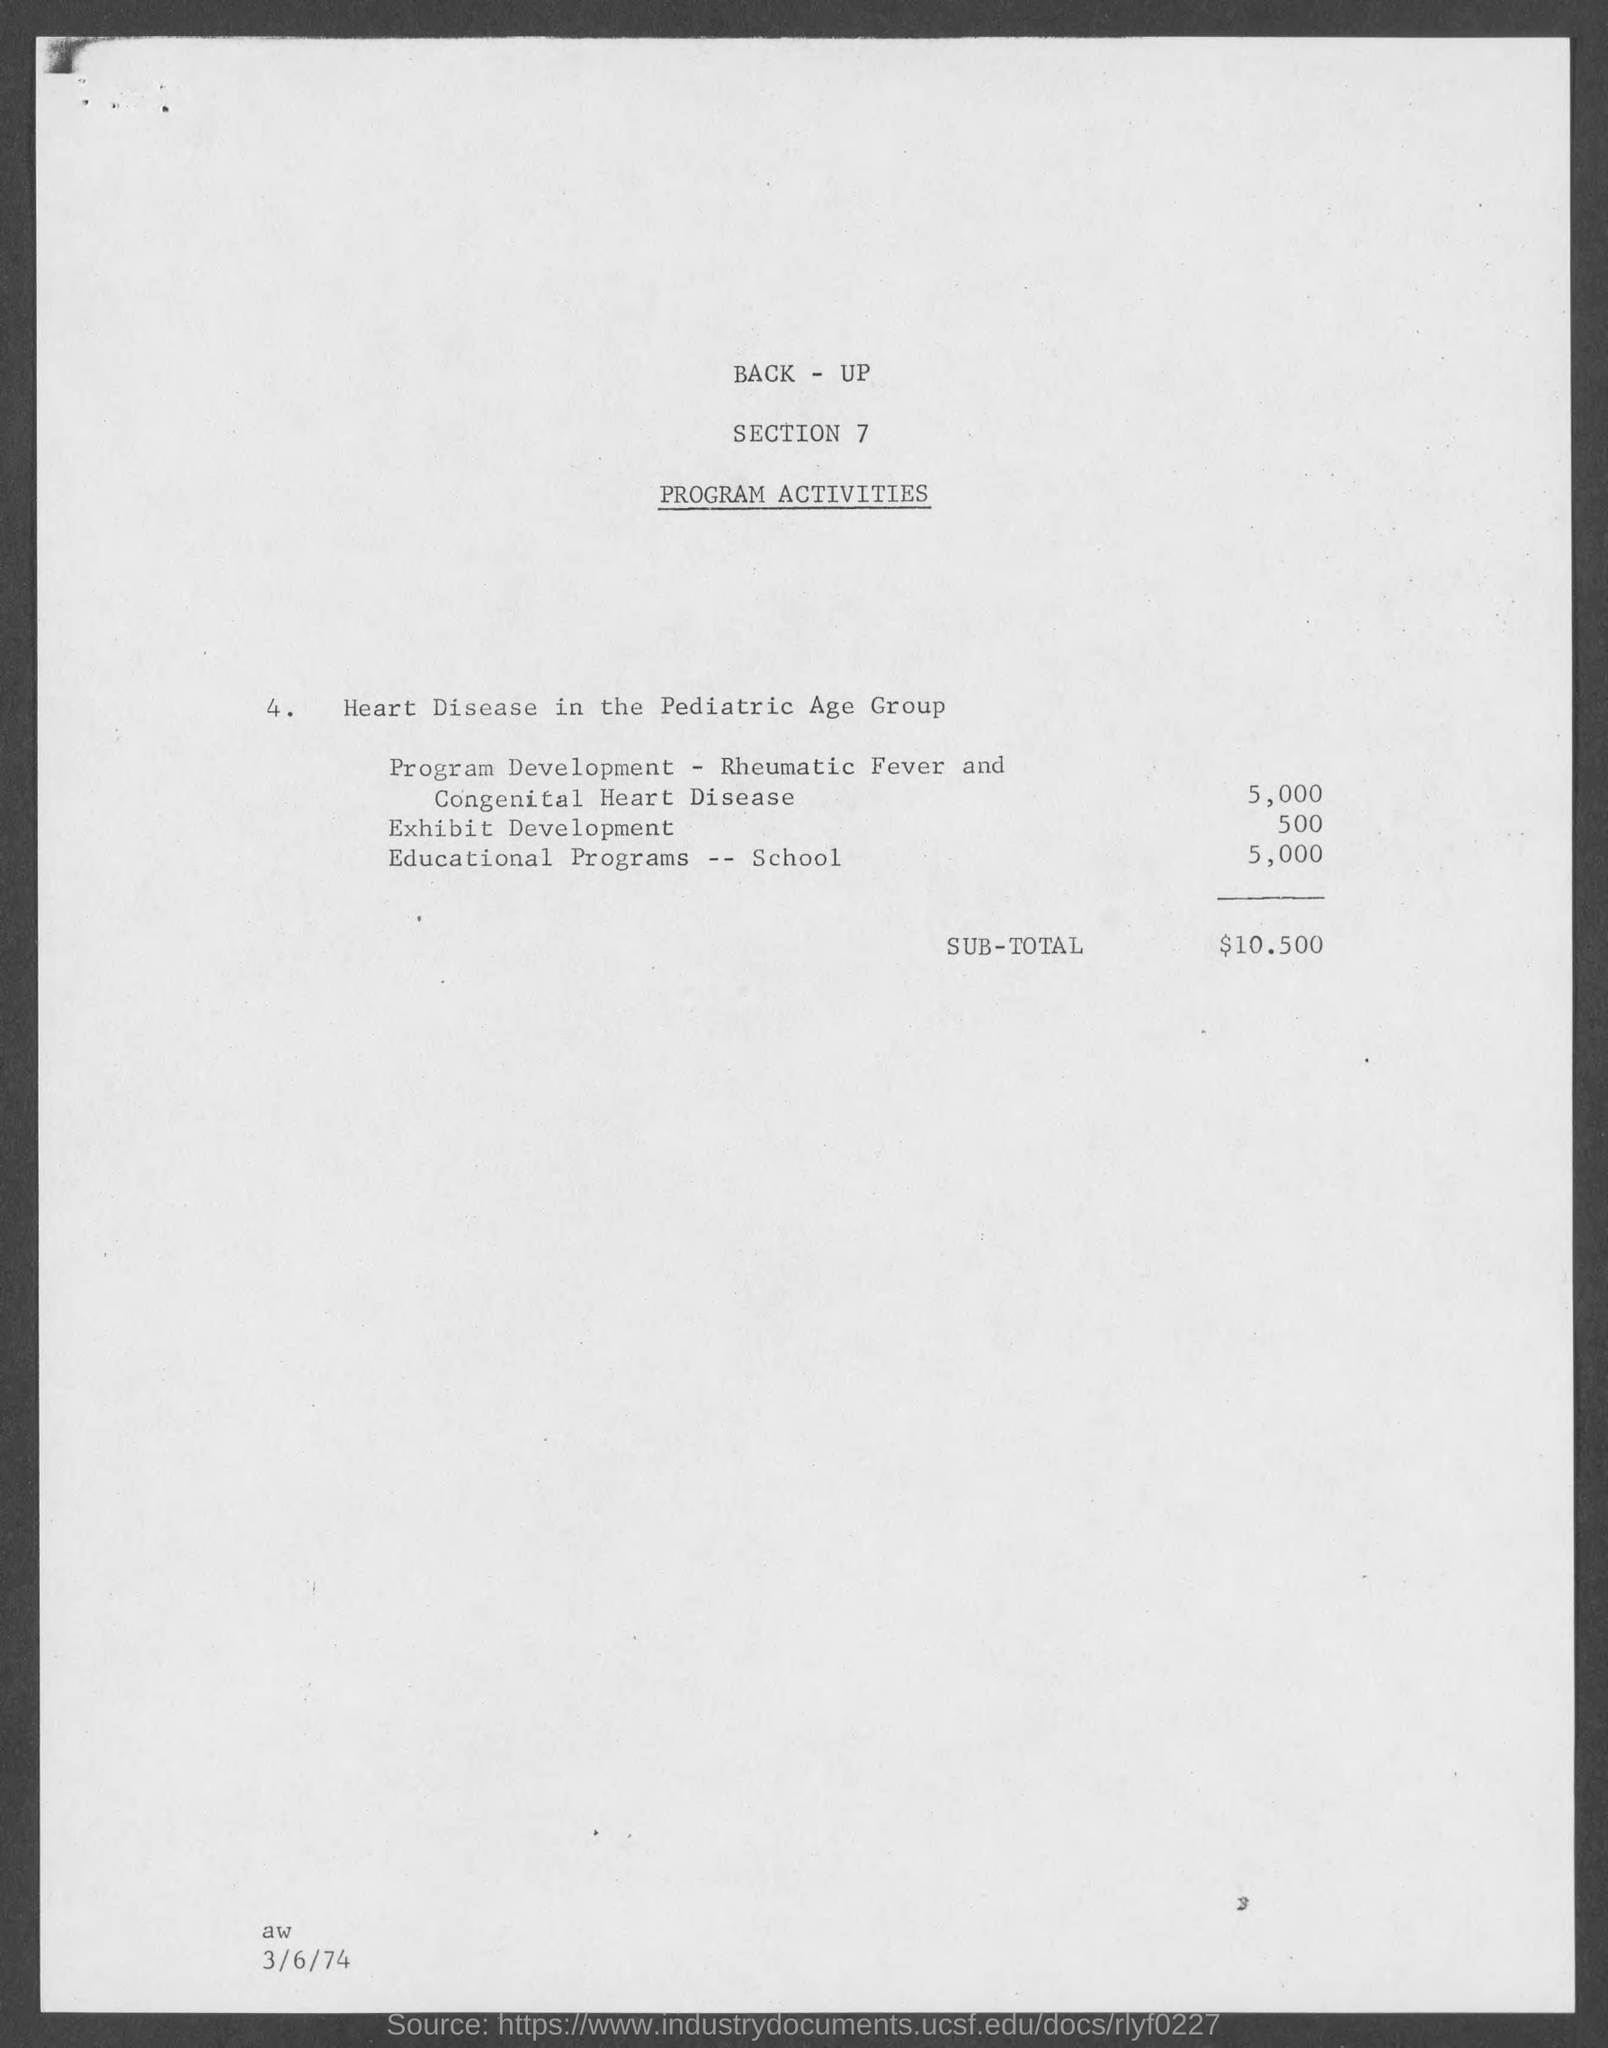What is the cost for Program development - Rheumatic Fever and Congenital Heart Disease?
Ensure brevity in your answer.  5,000. What is the cost for Exhibit Development?
Your response must be concise. 500. What is the cost for Educational Programs - School?
Keep it short and to the point. 5,000. What is the Sub-Total?
Your response must be concise. $10 500. 